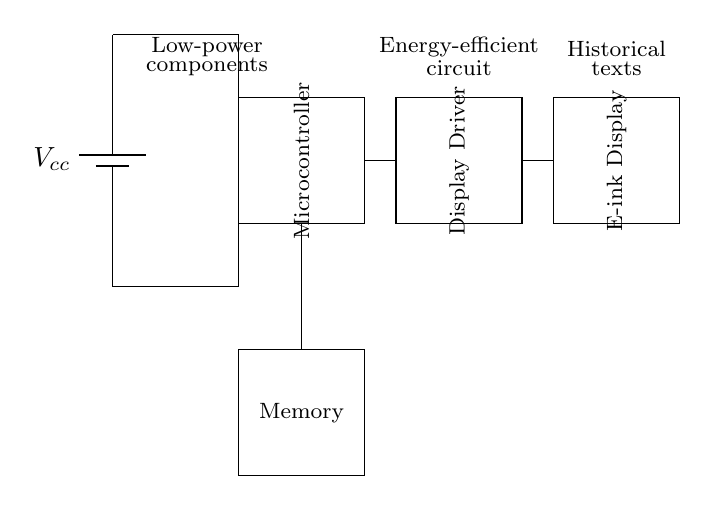What is the main power source of this circuit? The main power source is represented by the battery symbol labeled Vcc, which provides voltage to the circuit.
Answer: Vcc What are the major components in the circuit? The major components include a Microcontroller, Display Driver, E-ink Display, and Memory, all of which are depicted as rectangles in the circuit.
Answer: Microcontroller, Display Driver, E-ink Display, Memory How does the Microcontroller connect to the Memory? The Microcontroller connects to the Memory through a vertical line in the diagram, indicating a direct electrical connection between these two components.
Answer: Direct connection What is the purpose of the Display Driver? The Display Driver is responsible for controlling the E-ink Display, indicated by its placement directly next to and connected to the E-ink Display in the circuit.
Answer: Control the E-ink Display What type of circuit is this diagram representing? This diagram represents an energy-efficient display driver circuit designed specifically for e-ink readers, which are optimized for low power consumption.
Answer: Energy-efficient display driver circuit Explain how the circuit achieves energy efficiency. The circuit includes low-power components indicated at the top, which are designed to reduce overall power consumption while maintaining functionality for displaying historical texts on the E-ink display. By minimizing energy usage, the circuit enhances the battery life for users.
Answer: Low-power components 